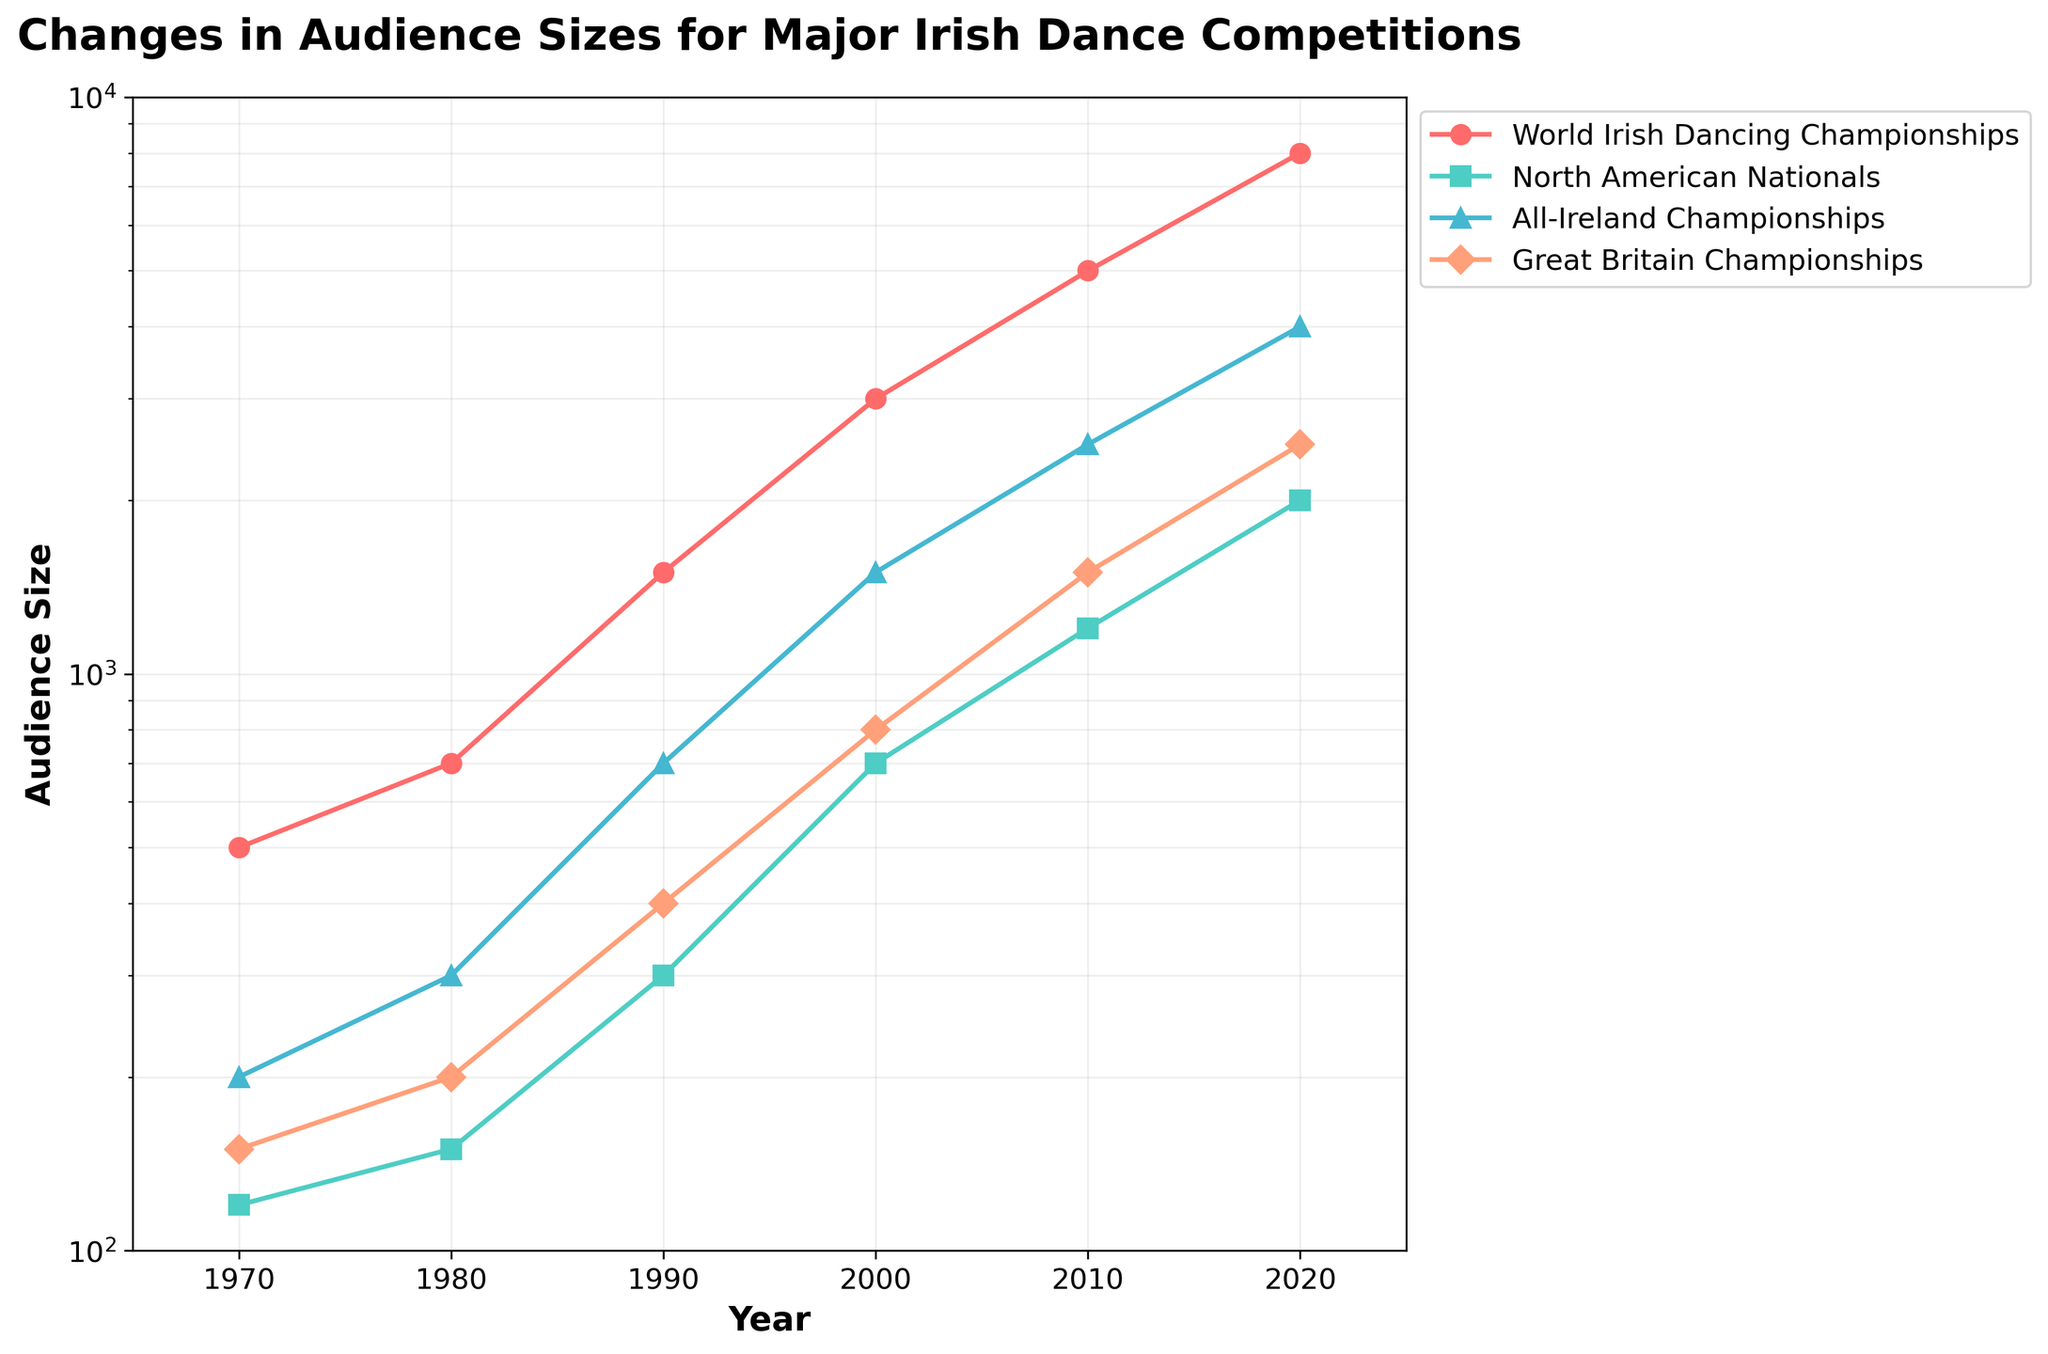Which competition had the largest audience size in 2020? The figure shows that the World Irish Dancing Championships had the largest audience size in 2020.
Answer: World Irish Dancing Championships What is the title of the figure? The title is clearly stated at the top of the figure.
Answer: Changes in Audience Sizes for Major Irish Dance Competitions How does the audience size for the North American Nationals in 2010 compare to that in 2020? The audience size for North American Nationals in 2010 was 1200, and in 2020 it increased to 2000.
Answer: It increased What is the smallest audience size recorded in the figure? By examining the log scale, the smallest audience size recorded is 120 for the North American Nationals in 1970.
Answer: 120 Which competition had the greatest relative increase in audience size from 1970 to 2020? To determine the relative increase, calculate the ratio of the final audience size to the initial size for each competition. The World Irish Dancing Championships had the largest relative increase from 500 to 8000 (a factor of 16).
Answer: World Irish Dancing Championships What trend do you observe for the audience size of the Great Britain Championships from 1970 to 2020? The audience size for the Great Britain Championships shows a general increasing trend from 150 to 2500.
Answer: Increasing trend Between 1980 and 1990, which competition saw the highest absolute increase in audience size? The highest absolute increase can be calculated by the difference in audience sizes between 1980 and 1990. The World Irish Dancing Championships saw an increase from 700 to 1500 (an increase of 800).
Answer: World Irish Dancing Championships By how much did the audience size of the All-Ireland Championships increase between 2000 and 2010? The audience size increased from 1500 in 2000 to 2500 in 2010. The increase is 2500 - 1500 = 1000.
Answer: 1000 What is the general trend observed in audience sizes for all competitions over the period from 1970 to 2020? All competitions show increasing trends in their audience sizes over the given period.
Answer: Increasing trend 